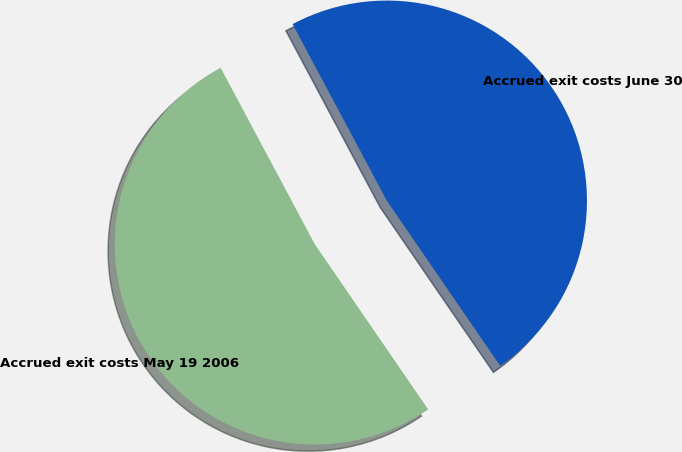<chart> <loc_0><loc_0><loc_500><loc_500><pie_chart><fcel>Accrued exit costs May 19 2006<fcel>Accrued exit costs June 30<nl><fcel>51.77%<fcel>48.23%<nl></chart> 